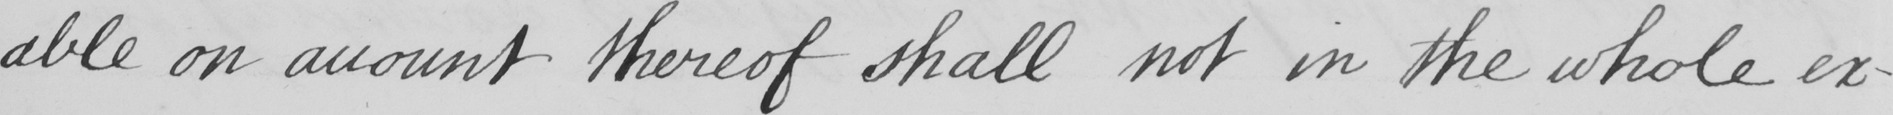What is written in this line of handwriting? -able on account thereof shall not in the whole ex- 